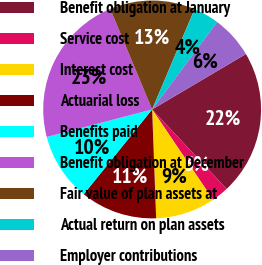Convert chart to OTSL. <chart><loc_0><loc_0><loc_500><loc_500><pie_chart><fcel>Benefit obligation at January<fcel>Service cost<fcel>Interest cost<fcel>Actuarial loss<fcel>Benefits paid<fcel>Benefit obligation at December<fcel>Fair value of plan assets at<fcel>Actual return on plan assets<fcel>Employer contributions<nl><fcel>21.52%<fcel>2.53%<fcel>8.86%<fcel>11.39%<fcel>10.13%<fcel>22.78%<fcel>12.66%<fcel>3.8%<fcel>6.33%<nl></chart> 